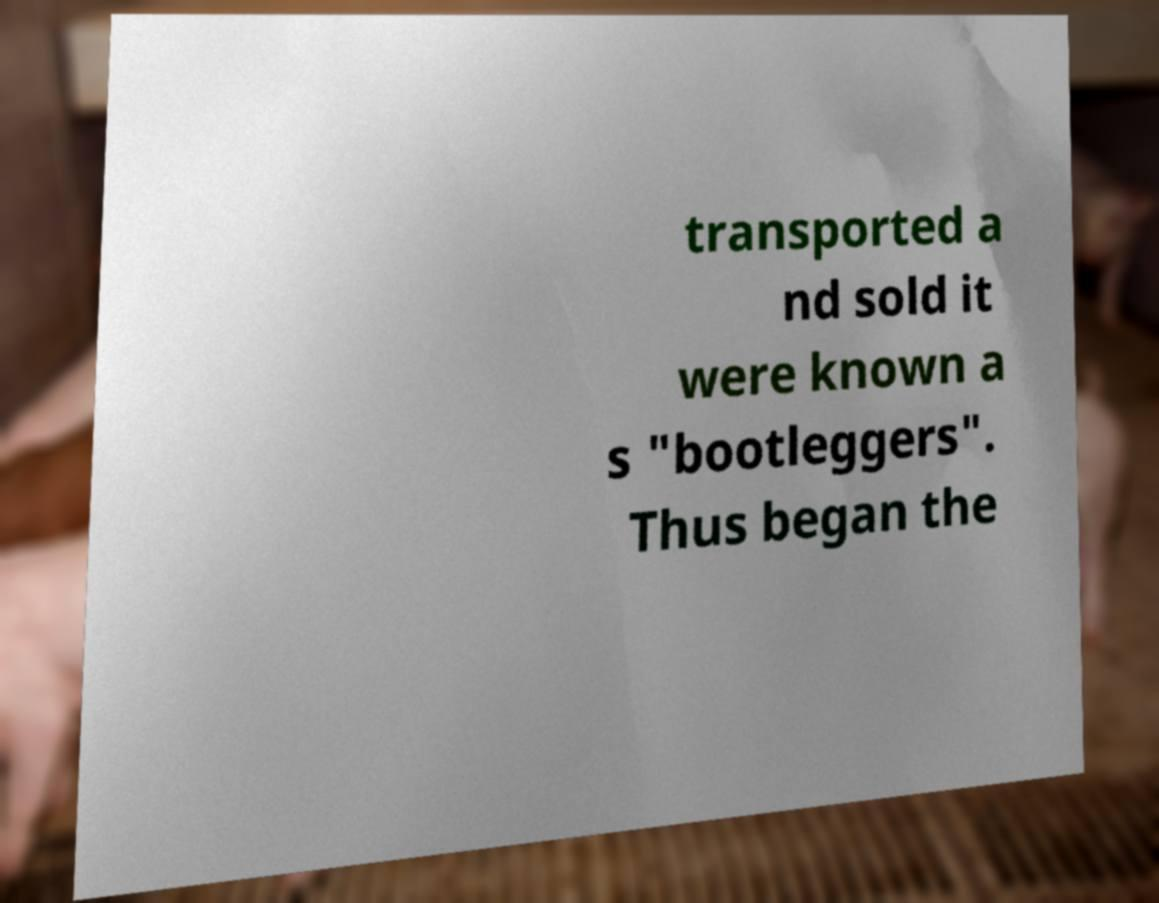Can you accurately transcribe the text from the provided image for me? transported a nd sold it were known a s "bootleggers". Thus began the 